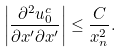Convert formula to latex. <formula><loc_0><loc_0><loc_500><loc_500>\left | \frac { \partial ^ { 2 } u _ { 0 } ^ { c } } { \partial x ^ { \prime } \partial x ^ { \prime } } \right | \leq \frac { C } { x _ { n } ^ { 2 } } .</formula> 